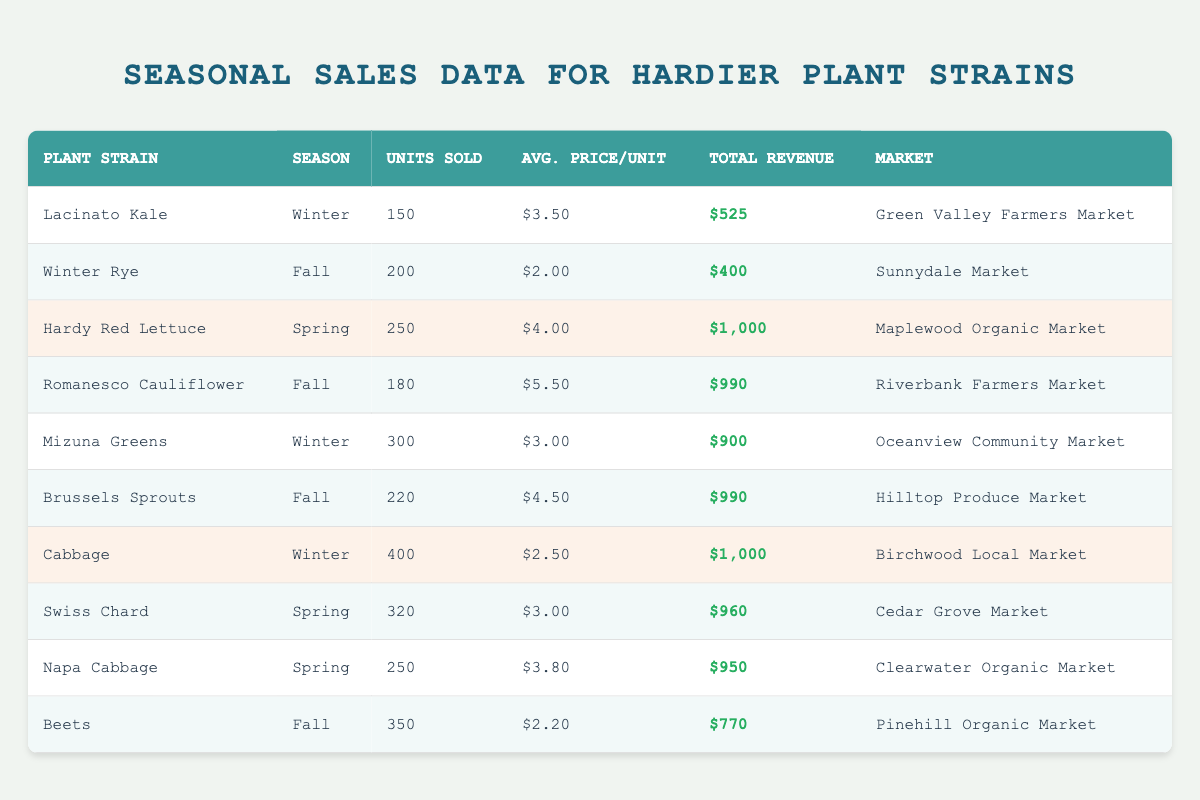What is the total revenue generated from the sale of Lacinato Kale? The table shows that Lacinato Kale generated a total revenue of $525.
Answer: $525 Which plant strain had the highest units sold in the data? The plant strain with the highest units sold is Cabbage with 400 units sold.
Answer: Cabbage What is the average price per unit of Hardy Red Lettuce? The average price per unit of Hardy Red Lettuce is $4.00.
Answer: $4.00 What season did the market with the highest total revenue occur? The highest total revenue of $1,000 is from Cabbage in the Winter season. Therefore, the season with the highest total revenue is Winter.
Answer: Winter Which market sold Brussels Sprouts? Brussels Sprouts were sold at Hilltop Produce Market.
Answer: Hilltop Produce Market How much revenue was generated from the sales of Swiss Chard and Napa Cabbage combined? Swiss Chard generated $960 and Napa Cabbage generated $950, combining these gives $960 + $950 = $1910.
Answer: $1910 Is the average price per unit for Mizuna Greens higher than $2.50? The average price per unit for Mizuna Greens is $3.00, which is higher than $2.50.
Answer: Yes If we compare units sold in Winter to those in Spring, which season had more units sold overall? In Winter, a total of 150 (Lacinato Kale) + 300 (Mizuna Greens) + 400 (Cabbage) = 850 units were sold, and in Spring, a total of 250 (Hardy Red Lettuce) + 320 (Swiss Chard) + 250 (Napa Cabbage) = 820 units were sold. Since 850 is greater than 820, Winter had more units sold.
Answer: Winter What is the difference in total revenue between Romanesco Cauliflower and Beets? Romanesco Cauliflower generated $990 while Beets generated $770. The difference is $990 - $770 = $220.
Answer: $220 Does any plant strain have a lower average price per unit than Beets at $2.20? Cabbage has an average price of $2.50, and Winter Rye has an average price of $2.00, which is lower. Therefore, yes, there are plant strains with lower prices.
Answer: Yes 